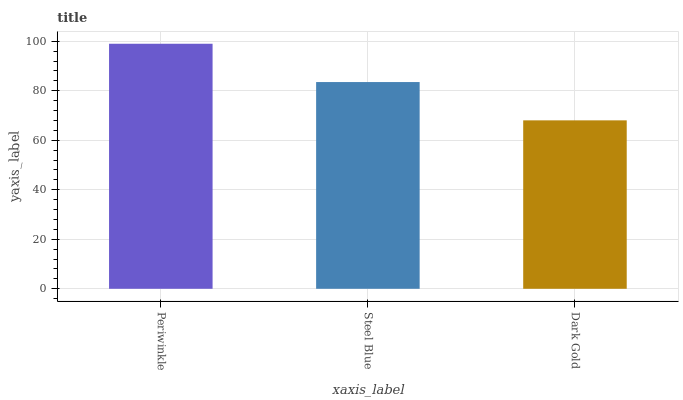Is Steel Blue the minimum?
Answer yes or no. No. Is Steel Blue the maximum?
Answer yes or no. No. Is Periwinkle greater than Steel Blue?
Answer yes or no. Yes. Is Steel Blue less than Periwinkle?
Answer yes or no. Yes. Is Steel Blue greater than Periwinkle?
Answer yes or no. No. Is Periwinkle less than Steel Blue?
Answer yes or no. No. Is Steel Blue the high median?
Answer yes or no. Yes. Is Steel Blue the low median?
Answer yes or no. Yes. Is Periwinkle the high median?
Answer yes or no. No. Is Periwinkle the low median?
Answer yes or no. No. 